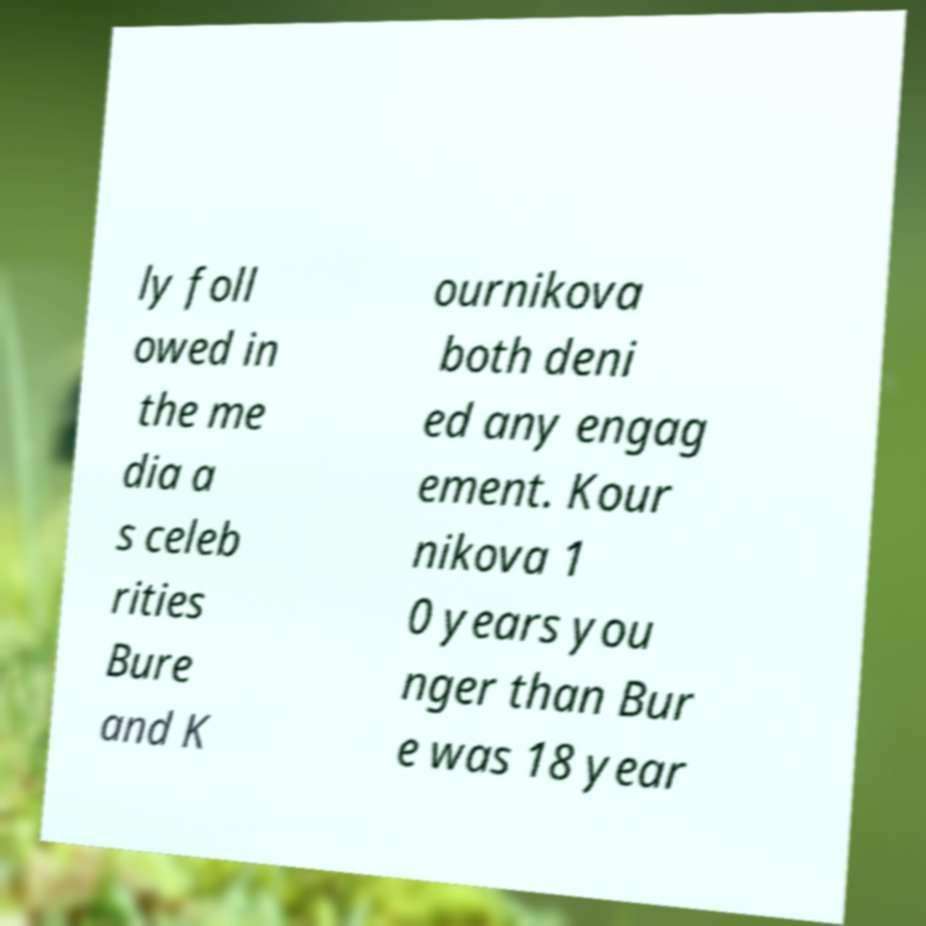There's text embedded in this image that I need extracted. Can you transcribe it verbatim? ly foll owed in the me dia a s celeb rities Bure and K ournikova both deni ed any engag ement. Kour nikova 1 0 years you nger than Bur e was 18 year 